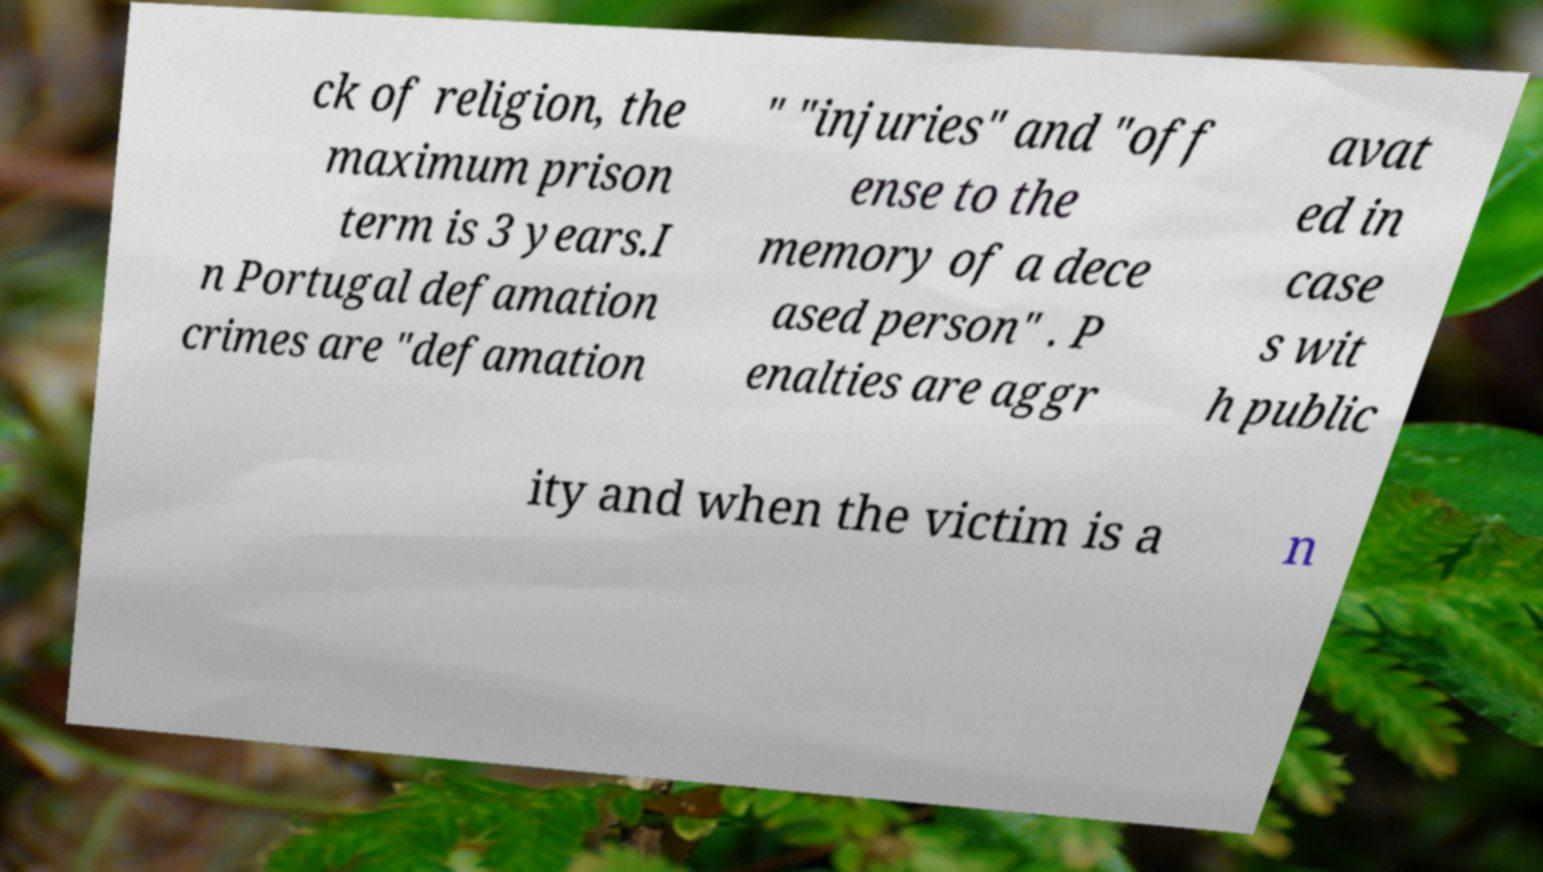What messages or text are displayed in this image? I need them in a readable, typed format. ck of religion, the maximum prison term is 3 years.I n Portugal defamation crimes are "defamation " "injuries" and "off ense to the memory of a dece ased person" . P enalties are aggr avat ed in case s wit h public ity and when the victim is a n 